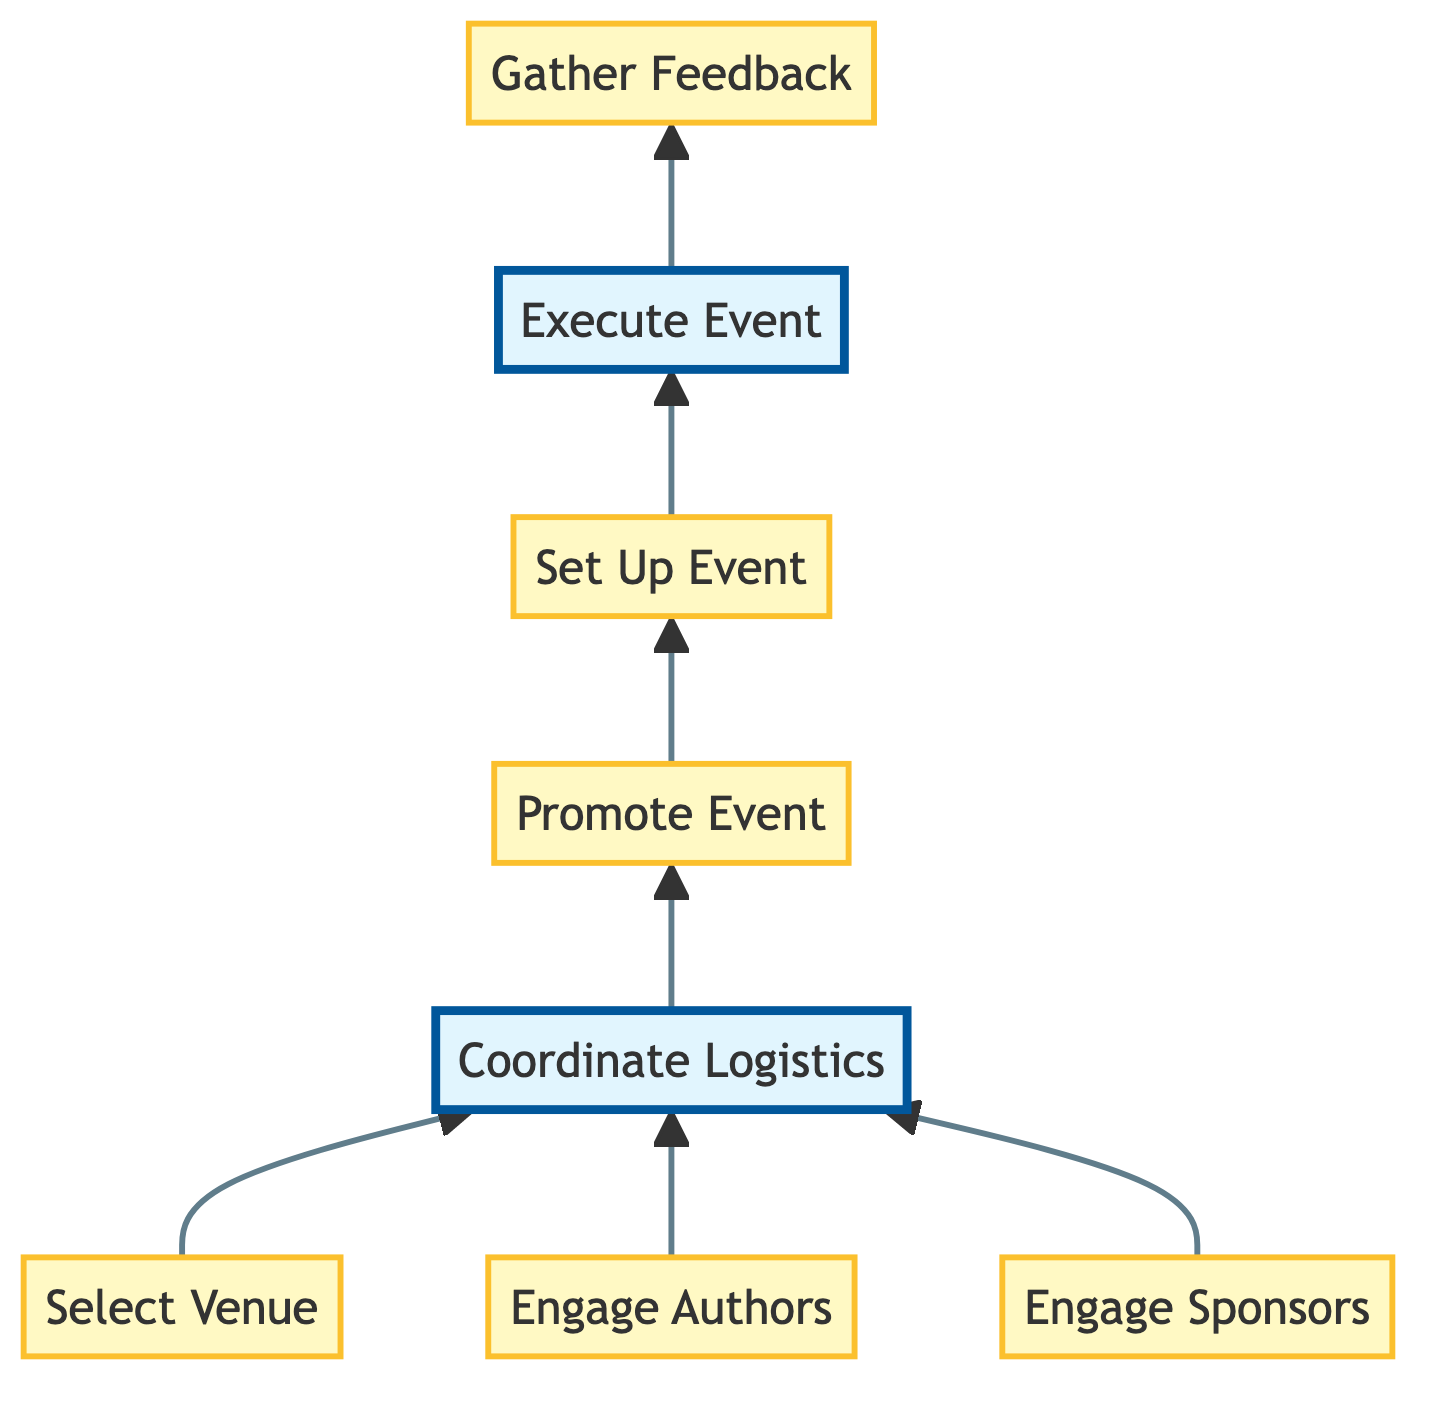What is the first step in the event organization process? The diagram indicates that the first step is "Select Venue," as it is the topmost node in the flow chart.
Answer: Select Venue How many nodes are present in the diagram? Counting each individual step represents a node; starting from "Select Venue" to "Gather Feedback," there are a total of 8 nodes.
Answer: 8 What action occurs immediately after "Promote Event"? In the flow of the diagram, the action that follows "Promote Event" is "Set Up Event." This showcases the sequence of steps leading up to the execution of the event.
Answer: Set Up Event Which process is highlighted in the diagram? The two highlighted processes, shown with a distinct style, are "Coordinate Logistics" and "Execute Event," indicating their significance in the overall event organization flow.
Answer: Coordinate Logistics, Execute Event What is the relationship between "Engage Authors" and "Promote Event"? "Engage Authors" is connected to "Coordinate Logistics," which then leads to "Promote Event," demonstrating that engaging authors is an essential precursor to promoting the event.
Answer: Engages through Coordinate Logistics What is the last step of the flow chart? The final action in the flow, depicted at the bottom of the chart, is "Gather Feedback," indicating that this is the concluding activity after the event.
Answer: Gather Feedback Which step is executed after the event setup? According to the flowchart, directly following "Set Up Event," the next step is "Execute Event," signifying the transition from preparation to actual execution.
Answer: Execute Event How does "Engage Sponsors" connect with the other steps? "Engage Sponsors" flows into "Coordinate Logistics," which then links to "Promote Event." This indicates that engaging sponsors is part of the groundwork influencing logistics and promotion.
Answer: Connects to Coordinate Logistics 